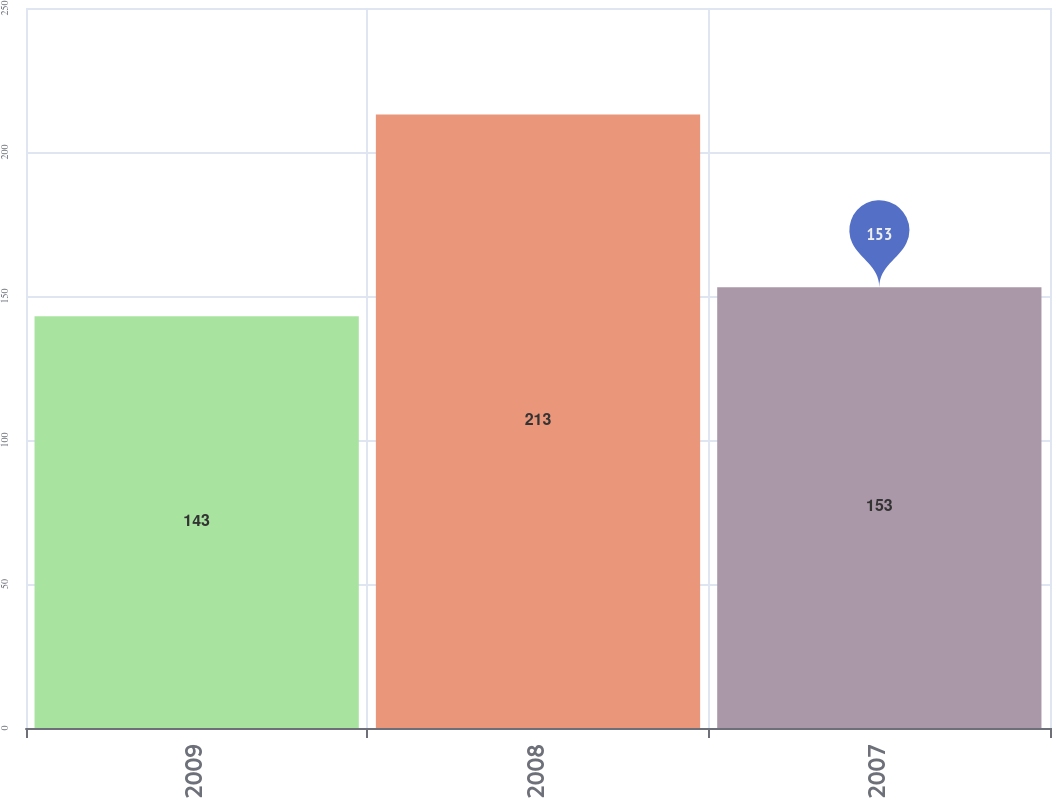<chart> <loc_0><loc_0><loc_500><loc_500><bar_chart><fcel>2009<fcel>2008<fcel>2007<nl><fcel>143<fcel>213<fcel>153<nl></chart> 